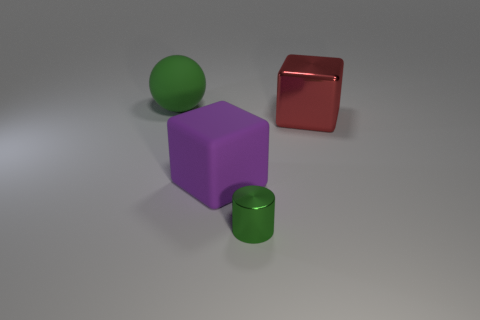Do the big object in front of the big red thing and the big red metal thing have the same shape?
Ensure brevity in your answer.  Yes. Is the number of purple matte objects that are in front of the purple rubber block greater than the number of large matte things that are on the left side of the large rubber ball?
Keep it short and to the point. No. What number of cylinders are the same material as the small green object?
Provide a short and direct response. 0. Do the purple rubber cube and the shiny cube have the same size?
Offer a very short reply. Yes. What is the color of the large sphere?
Provide a short and direct response. Green. What number of objects are either big green rubber balls or big metal objects?
Offer a very short reply. 2. Are there any red metal objects of the same shape as the big purple rubber object?
Give a very brief answer. Yes. Do the metal object in front of the large metallic cube and the large sphere have the same color?
Your answer should be compact. Yes. What shape is the matte thing that is in front of the large block on the right side of the small green metal cylinder?
Offer a very short reply. Cube. Is there a green ball of the same size as the shiny block?
Keep it short and to the point. Yes. 